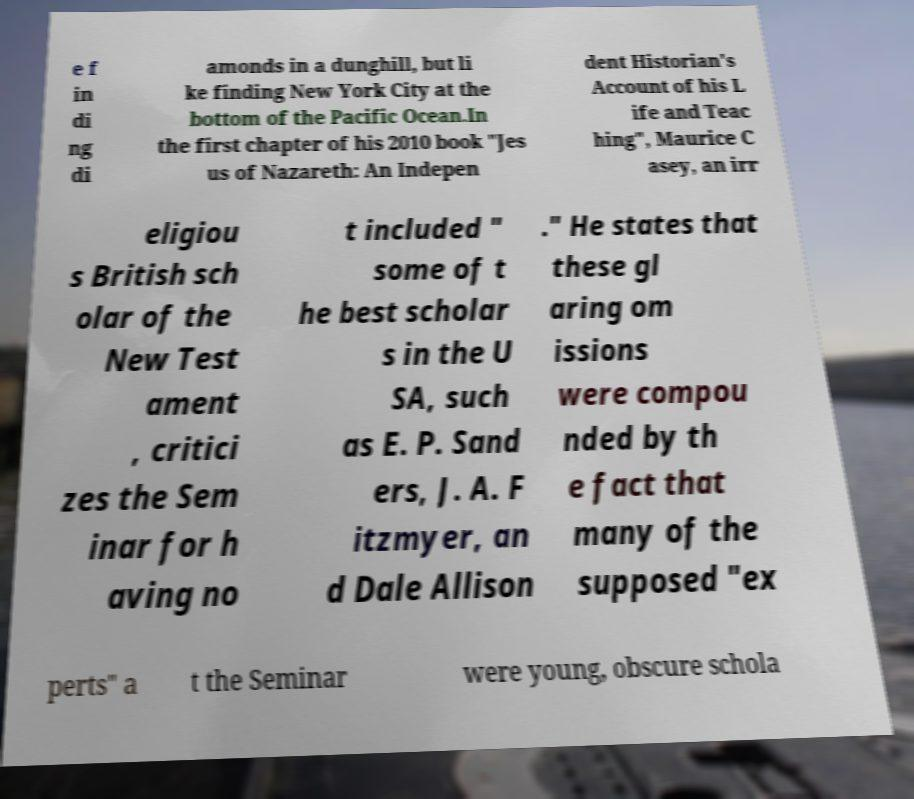Could you extract and type out the text from this image? e f in di ng di amonds in a dunghill, but li ke finding New York City at the bottom of the Pacific Ocean.In the first chapter of his 2010 book "Jes us of Nazareth: An Indepen dent Historian's Account of his L ife and Teac hing", Maurice C asey, an irr eligiou s British sch olar of the New Test ament , critici zes the Sem inar for h aving no t included " some of t he best scholar s in the U SA, such as E. P. Sand ers, J. A. F itzmyer, an d Dale Allison ." He states that these gl aring om issions were compou nded by th e fact that many of the supposed "ex perts" a t the Seminar were young, obscure schola 